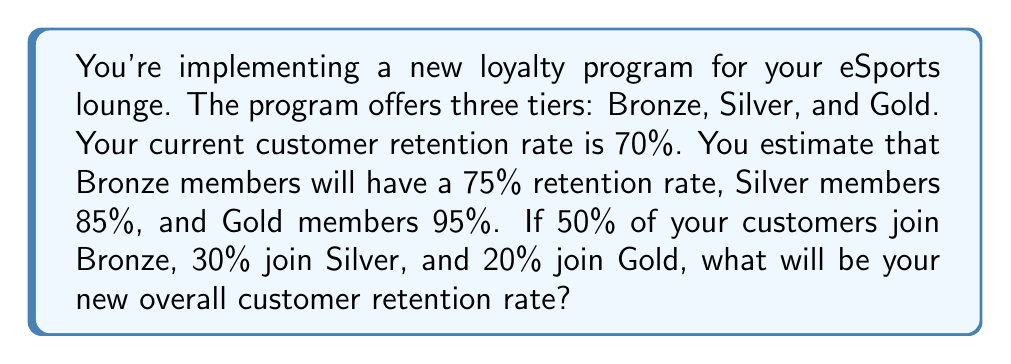Provide a solution to this math problem. Let's approach this step-by-step:

1) First, we need to calculate the weighted average of the retention rates for customers in the loyalty program:

   Bronze: $0.50 \times 0.75 = 0.375$
   Silver: $0.30 \times 0.85 = 0.255$
   Gold:   $0.20 \times 0.95 = 0.190$

2) Sum these values:

   $0.375 + 0.255 + 0.190 = 0.820$

   This means that 82% of customers in the loyalty program will be retained.

3) However, this only applies to customers who join the program. We need to account for those who don't join.

4) Let's assume $x$ is the proportion of customers who join the loyalty program. We don't know this value, so we'll leave it as a variable.

5) We can now set up an equation:

   New retention rate = (Proportion in program × Program retention rate) + (Proportion not in program × Original retention rate)

   $$ \text{New Rate} = x(0.820) + (1-x)(0.70) $$

6) Simplify:

   $$ \text{New Rate} = 0.820x + 0.70 - 0.70x = 0.70 + 0.12x $$

7) This equation shows that for every 1% increase in program participation, the overall retention rate will increase by 0.12%.

8) To find the exact new retention rate, we would need to know the value of $x$. However, we can conclude that the new retention rate will be between 70% (if no one joins) and 82% (if everyone joins).
Answer: $0.70 + 0.12x$, where $x$ is the proportion of customers joining the loyalty program 